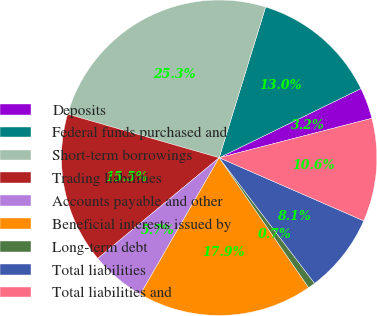<chart> <loc_0><loc_0><loc_500><loc_500><pie_chart><fcel>Deposits<fcel>Federal funds purchased and<fcel>Short-term borrowings<fcel>Trading liabilities<fcel>Accounts payable and other<fcel>Beneficial interests issued by<fcel>Long-term debt<fcel>Total liabilities<fcel>Total liabilities and<nl><fcel>3.2%<fcel>13.02%<fcel>25.3%<fcel>15.48%<fcel>5.65%<fcel>17.93%<fcel>0.74%<fcel>8.11%<fcel>10.57%<nl></chart> 